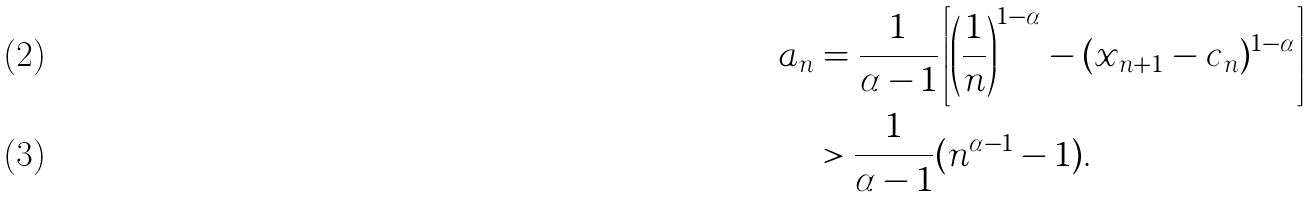Convert formula to latex. <formula><loc_0><loc_0><loc_500><loc_500>a _ { n } & = \frac { 1 } { \alpha - 1 } \left [ \left ( \frac { 1 } { n } \right ) ^ { 1 - \alpha } - ( x _ { n + 1 } - c _ { n } ) ^ { 1 - \alpha } \right ] \\ & > \frac { 1 } { \alpha - 1 } ( n ^ { \alpha - 1 } - 1 ) .</formula> 